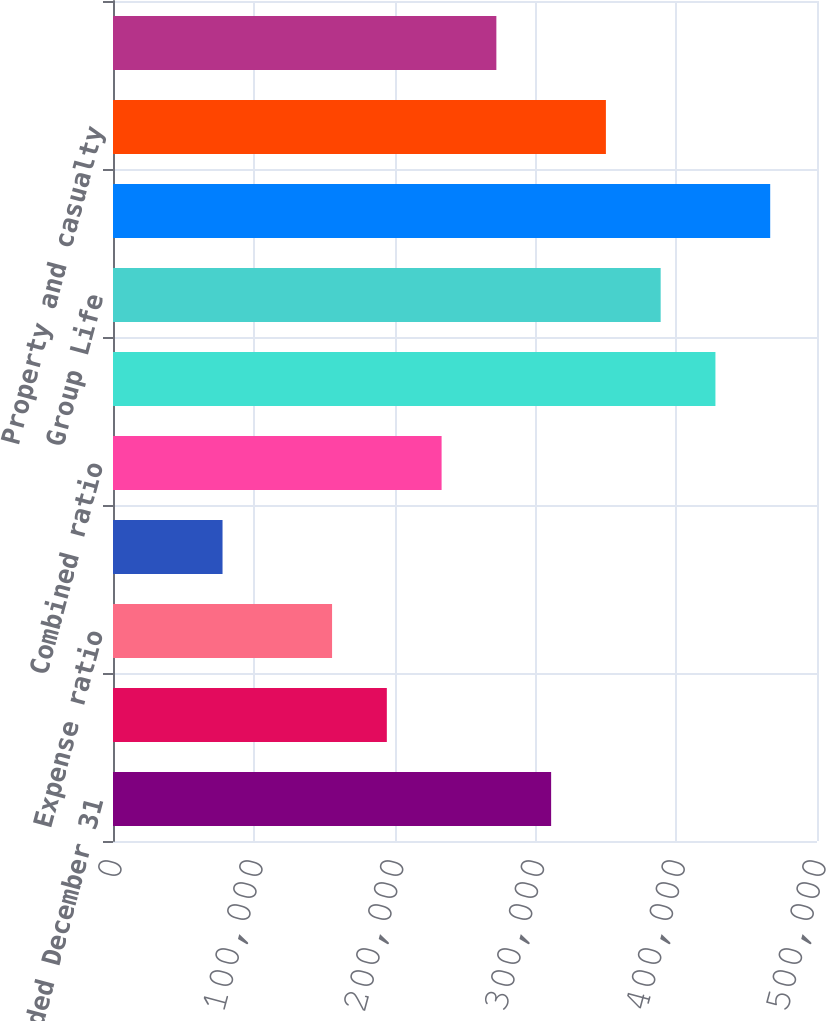Convert chart to OTSL. <chart><loc_0><loc_0><loc_500><loc_500><bar_chart><fcel>Year Ended December 31<fcel>Loss and loss adjustment<fcel>Expense ratio<fcel>Dividend ratio<fcel>Combined ratio<fcel>Individual Life<fcel>Group Life<fcel>Total<fcel>Property and casualty<fcel>Life and group companies'<nl><fcel>311174<fcel>194484<fcel>155588<fcel>77794<fcel>233381<fcel>427865<fcel>388968<fcel>466762<fcel>350071<fcel>272278<nl></chart> 